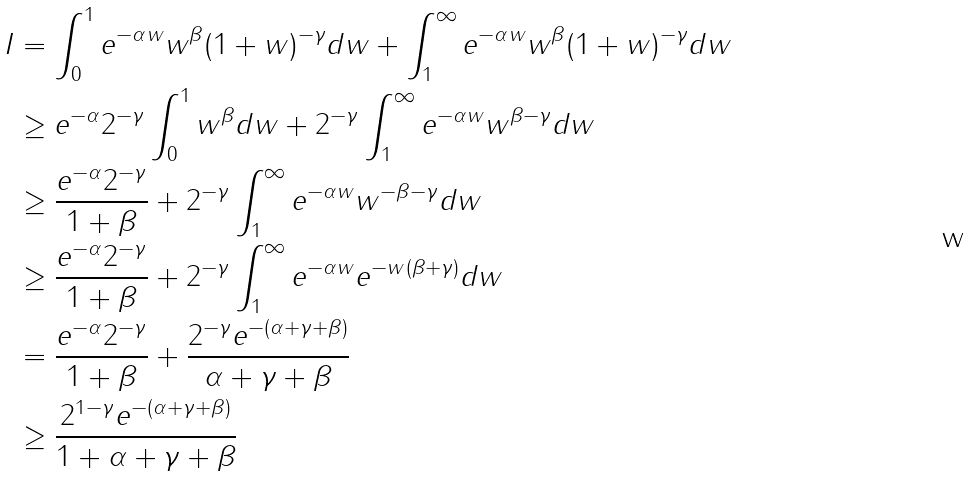<formula> <loc_0><loc_0><loc_500><loc_500>I & = \int _ { 0 } ^ { 1 } e ^ { - \alpha w } w ^ { \beta } ( 1 + w ) ^ { - \gamma } d w + \int _ { 1 } ^ { \infty } e ^ { - \alpha w } w ^ { \beta } ( 1 + w ) ^ { - \gamma } d w \\ & \geq e ^ { - \alpha } 2 ^ { - \gamma } \int _ { 0 } ^ { 1 } w ^ { \beta } d w + 2 ^ { - \gamma } \int _ { 1 } ^ { \infty } e ^ { - \alpha w } w ^ { \beta - \gamma } d w \\ & \geq \frac { e ^ { - \alpha } 2 ^ { - \gamma } } { 1 + \beta } + 2 ^ { - \gamma } \int _ { 1 } ^ { \infty } e ^ { - \alpha w } w ^ { - \beta - \gamma } d w \\ & \geq \frac { e ^ { - \alpha } 2 ^ { - \gamma } } { 1 + \beta } + 2 ^ { - \gamma } \int _ { 1 } ^ { \infty } e ^ { - \alpha w } e ^ { - w ( \beta + \gamma ) } d w \\ & = \frac { e ^ { - \alpha } 2 ^ { - \gamma } } { 1 + \beta } + \frac { 2 ^ { - \gamma } e ^ { - ( \alpha + \gamma + \beta ) } } { \alpha + \gamma + \beta } \\ & \geq \frac { 2 ^ { 1 - \gamma } e ^ { - ( \alpha + \gamma + \beta ) } } { 1 + \alpha + \gamma + \beta }</formula> 